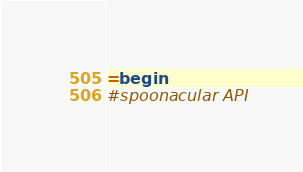Convert code to text. <code><loc_0><loc_0><loc_500><loc_500><_Ruby_>=begin
#spoonacular API
</code> 